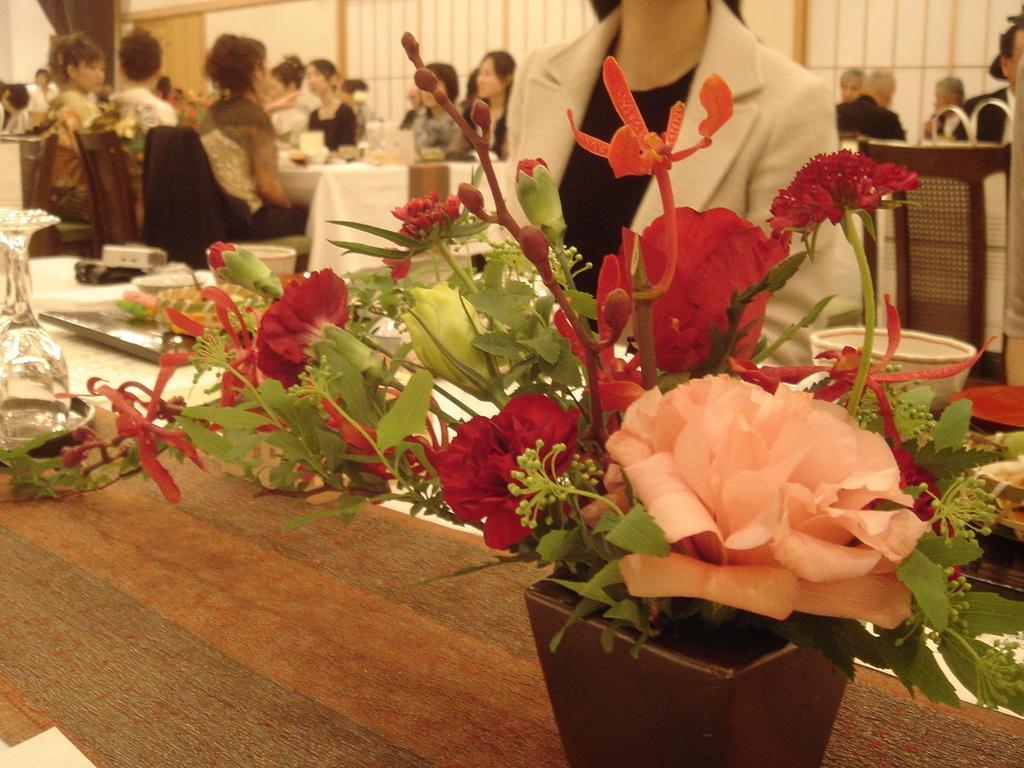Can you describe this image briefly? In the foreground of the image we can see group of flowers and leaves placed in a pot. On the left side of the image we can see a group of bowls and glass placed on the table. In the background, we can see a group of people sitting on chairs, some objects placed on the table and the wall. 